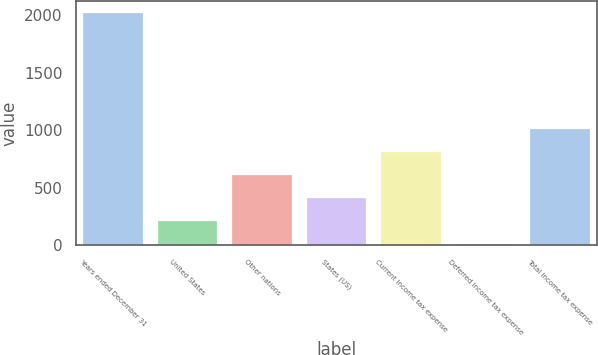Convert chart to OTSL. <chart><loc_0><loc_0><loc_500><loc_500><bar_chart><fcel>Years ended December 31<fcel>United States<fcel>Other nations<fcel>States (US)<fcel>Current income tax expense<fcel>Deferred income tax expense<fcel>Total income tax expense<nl><fcel>2018<fcel>209.9<fcel>611.7<fcel>410.8<fcel>812.6<fcel>9<fcel>1013.5<nl></chart> 